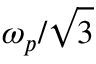Convert formula to latex. <formula><loc_0><loc_0><loc_500><loc_500>\omega _ { p } / \sqrt { 3 }</formula> 